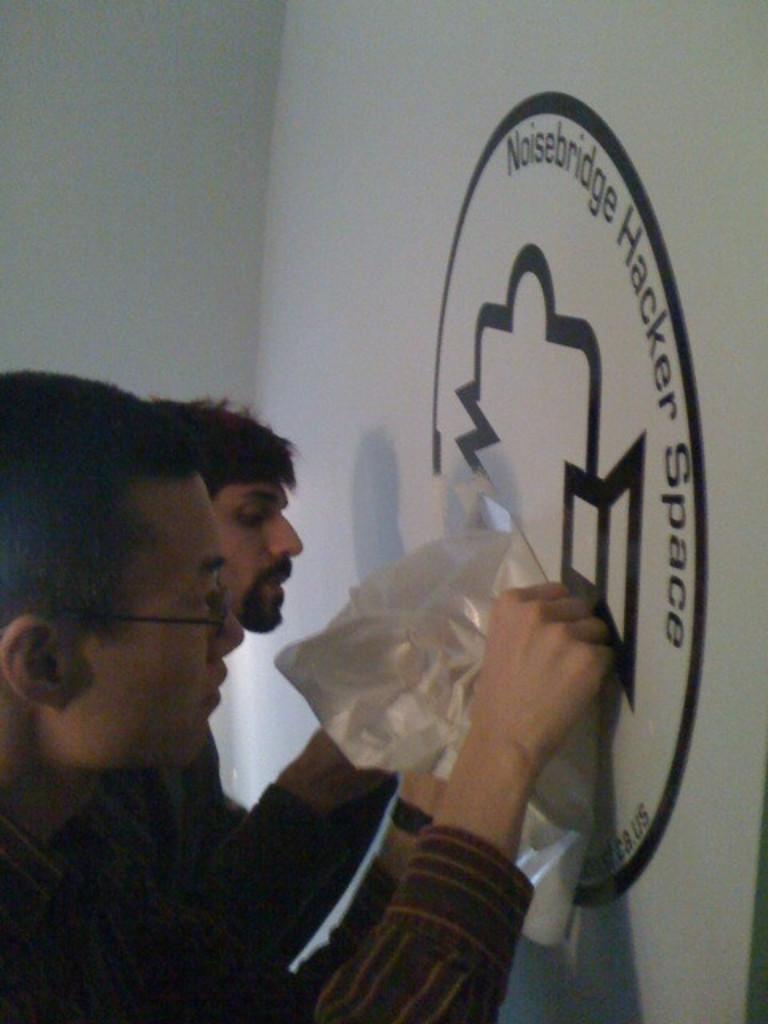In one or two sentences, can you explain what this image depicts? I can see two people standing. I think they were painting on the wall. This looks like a logo on the wall, which is white in color. 